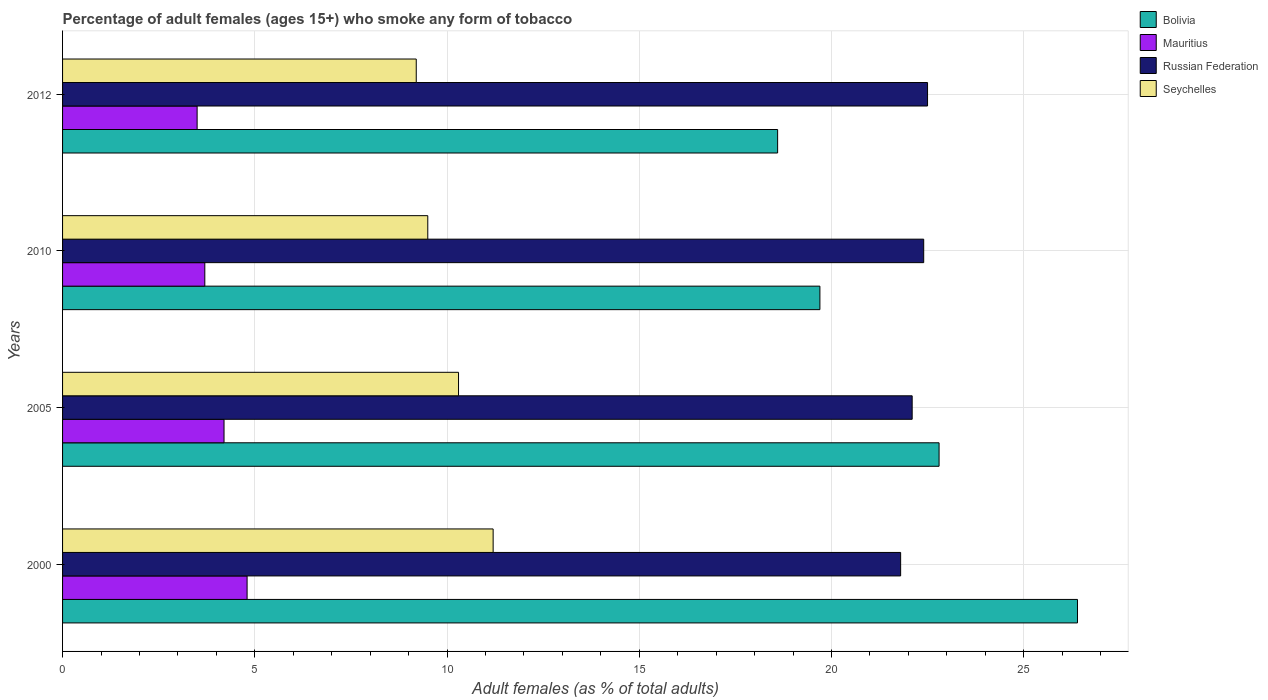How many bars are there on the 4th tick from the top?
Provide a short and direct response. 4. How many bars are there on the 3rd tick from the bottom?
Provide a succinct answer. 4. What is the label of the 2nd group of bars from the top?
Offer a terse response. 2010. In how many cases, is the number of bars for a given year not equal to the number of legend labels?
Provide a short and direct response. 0. Across all years, what is the maximum percentage of adult females who smoke in Mauritius?
Ensure brevity in your answer.  4.8. What is the total percentage of adult females who smoke in Mauritius in the graph?
Your response must be concise. 16.2. What is the difference between the percentage of adult females who smoke in Bolivia in 2000 and that in 2010?
Your answer should be compact. 6.7. What is the difference between the percentage of adult females who smoke in Bolivia in 2000 and the percentage of adult females who smoke in Seychelles in 2012?
Your answer should be compact. 17.2. What is the average percentage of adult females who smoke in Mauritius per year?
Your answer should be compact. 4.05. In the year 2010, what is the difference between the percentage of adult females who smoke in Mauritius and percentage of adult females who smoke in Bolivia?
Your answer should be very brief. -16. What is the ratio of the percentage of adult females who smoke in Russian Federation in 2000 to that in 2010?
Provide a succinct answer. 0.97. Is the percentage of adult females who smoke in Bolivia in 2000 less than that in 2012?
Ensure brevity in your answer.  No. Is the difference between the percentage of adult females who smoke in Mauritius in 2000 and 2012 greater than the difference between the percentage of adult females who smoke in Bolivia in 2000 and 2012?
Keep it short and to the point. No. What is the difference between the highest and the second highest percentage of adult females who smoke in Russian Federation?
Offer a very short reply. 0.1. What is the difference between the highest and the lowest percentage of adult females who smoke in Bolivia?
Offer a very short reply. 7.8. In how many years, is the percentage of adult females who smoke in Seychelles greater than the average percentage of adult females who smoke in Seychelles taken over all years?
Provide a succinct answer. 2. What does the 1st bar from the top in 2005 represents?
Your response must be concise. Seychelles. What does the 1st bar from the bottom in 2005 represents?
Your answer should be compact. Bolivia. Is it the case that in every year, the sum of the percentage of adult females who smoke in Bolivia and percentage of adult females who smoke in Russian Federation is greater than the percentage of adult females who smoke in Seychelles?
Offer a very short reply. Yes. How many bars are there?
Provide a short and direct response. 16. Are all the bars in the graph horizontal?
Provide a short and direct response. Yes. How many years are there in the graph?
Your response must be concise. 4. Are the values on the major ticks of X-axis written in scientific E-notation?
Offer a very short reply. No. Does the graph contain any zero values?
Ensure brevity in your answer.  No. What is the title of the graph?
Your answer should be compact. Percentage of adult females (ages 15+) who smoke any form of tobacco. Does "Morocco" appear as one of the legend labels in the graph?
Provide a short and direct response. No. What is the label or title of the X-axis?
Offer a terse response. Adult females (as % of total adults). What is the Adult females (as % of total adults) in Bolivia in 2000?
Your answer should be compact. 26.4. What is the Adult females (as % of total adults) in Russian Federation in 2000?
Offer a terse response. 21.8. What is the Adult females (as % of total adults) of Bolivia in 2005?
Make the answer very short. 22.8. What is the Adult females (as % of total adults) of Russian Federation in 2005?
Your answer should be very brief. 22.1. What is the Adult females (as % of total adults) in Seychelles in 2005?
Offer a very short reply. 10.3. What is the Adult females (as % of total adults) of Mauritius in 2010?
Your answer should be compact. 3.7. What is the Adult females (as % of total adults) of Russian Federation in 2010?
Offer a terse response. 22.4. What is the Adult females (as % of total adults) in Bolivia in 2012?
Your response must be concise. 18.6. What is the Adult females (as % of total adults) in Mauritius in 2012?
Offer a terse response. 3.5. What is the Adult females (as % of total adults) in Seychelles in 2012?
Ensure brevity in your answer.  9.2. Across all years, what is the maximum Adult females (as % of total adults) in Bolivia?
Keep it short and to the point. 26.4. Across all years, what is the maximum Adult females (as % of total adults) of Mauritius?
Provide a succinct answer. 4.8. Across all years, what is the maximum Adult females (as % of total adults) of Seychelles?
Provide a short and direct response. 11.2. Across all years, what is the minimum Adult females (as % of total adults) of Mauritius?
Ensure brevity in your answer.  3.5. Across all years, what is the minimum Adult females (as % of total adults) in Russian Federation?
Your answer should be very brief. 21.8. What is the total Adult females (as % of total adults) in Bolivia in the graph?
Your answer should be compact. 87.5. What is the total Adult females (as % of total adults) of Russian Federation in the graph?
Ensure brevity in your answer.  88.8. What is the total Adult females (as % of total adults) in Seychelles in the graph?
Your response must be concise. 40.2. What is the difference between the Adult females (as % of total adults) of Mauritius in 2000 and that in 2005?
Offer a terse response. 0.6. What is the difference between the Adult females (as % of total adults) of Russian Federation in 2000 and that in 2005?
Your response must be concise. -0.3. What is the difference between the Adult females (as % of total adults) in Bolivia in 2000 and that in 2010?
Your response must be concise. 6.7. What is the difference between the Adult females (as % of total adults) in Mauritius in 2000 and that in 2010?
Your response must be concise. 1.1. What is the difference between the Adult females (as % of total adults) of Russian Federation in 2000 and that in 2010?
Offer a very short reply. -0.6. What is the difference between the Adult females (as % of total adults) in Mauritius in 2000 and that in 2012?
Your answer should be very brief. 1.3. What is the difference between the Adult females (as % of total adults) in Russian Federation in 2000 and that in 2012?
Your answer should be compact. -0.7. What is the difference between the Adult females (as % of total adults) in Seychelles in 2000 and that in 2012?
Offer a terse response. 2. What is the difference between the Adult females (as % of total adults) in Mauritius in 2005 and that in 2010?
Give a very brief answer. 0.5. What is the difference between the Adult females (as % of total adults) of Russian Federation in 2005 and that in 2010?
Give a very brief answer. -0.3. What is the difference between the Adult females (as % of total adults) in Bolivia in 2005 and that in 2012?
Give a very brief answer. 4.2. What is the difference between the Adult females (as % of total adults) of Russian Federation in 2005 and that in 2012?
Give a very brief answer. -0.4. What is the difference between the Adult females (as % of total adults) in Seychelles in 2005 and that in 2012?
Your answer should be very brief. 1.1. What is the difference between the Adult females (as % of total adults) of Bolivia in 2010 and that in 2012?
Provide a short and direct response. 1.1. What is the difference between the Adult females (as % of total adults) in Mauritius in 2010 and that in 2012?
Offer a very short reply. 0.2. What is the difference between the Adult females (as % of total adults) in Russian Federation in 2010 and that in 2012?
Provide a succinct answer. -0.1. What is the difference between the Adult females (as % of total adults) in Seychelles in 2010 and that in 2012?
Offer a terse response. 0.3. What is the difference between the Adult females (as % of total adults) of Bolivia in 2000 and the Adult females (as % of total adults) of Seychelles in 2005?
Make the answer very short. 16.1. What is the difference between the Adult females (as % of total adults) of Mauritius in 2000 and the Adult females (as % of total adults) of Russian Federation in 2005?
Make the answer very short. -17.3. What is the difference between the Adult females (as % of total adults) in Bolivia in 2000 and the Adult females (as % of total adults) in Mauritius in 2010?
Make the answer very short. 22.7. What is the difference between the Adult females (as % of total adults) in Mauritius in 2000 and the Adult females (as % of total adults) in Russian Federation in 2010?
Keep it short and to the point. -17.6. What is the difference between the Adult females (as % of total adults) in Russian Federation in 2000 and the Adult females (as % of total adults) in Seychelles in 2010?
Your answer should be compact. 12.3. What is the difference between the Adult females (as % of total adults) in Bolivia in 2000 and the Adult females (as % of total adults) in Mauritius in 2012?
Make the answer very short. 22.9. What is the difference between the Adult females (as % of total adults) of Bolivia in 2000 and the Adult females (as % of total adults) of Russian Federation in 2012?
Your answer should be very brief. 3.9. What is the difference between the Adult females (as % of total adults) of Bolivia in 2000 and the Adult females (as % of total adults) of Seychelles in 2012?
Your answer should be very brief. 17.2. What is the difference between the Adult females (as % of total adults) of Mauritius in 2000 and the Adult females (as % of total adults) of Russian Federation in 2012?
Provide a short and direct response. -17.7. What is the difference between the Adult females (as % of total adults) of Mauritius in 2000 and the Adult females (as % of total adults) of Seychelles in 2012?
Keep it short and to the point. -4.4. What is the difference between the Adult females (as % of total adults) in Bolivia in 2005 and the Adult females (as % of total adults) in Russian Federation in 2010?
Keep it short and to the point. 0.4. What is the difference between the Adult females (as % of total adults) in Bolivia in 2005 and the Adult females (as % of total adults) in Seychelles in 2010?
Your answer should be compact. 13.3. What is the difference between the Adult females (as % of total adults) of Mauritius in 2005 and the Adult females (as % of total adults) of Russian Federation in 2010?
Make the answer very short. -18.2. What is the difference between the Adult females (as % of total adults) in Russian Federation in 2005 and the Adult females (as % of total adults) in Seychelles in 2010?
Your answer should be compact. 12.6. What is the difference between the Adult females (as % of total adults) in Bolivia in 2005 and the Adult females (as % of total adults) in Mauritius in 2012?
Keep it short and to the point. 19.3. What is the difference between the Adult females (as % of total adults) of Bolivia in 2005 and the Adult females (as % of total adults) of Seychelles in 2012?
Provide a succinct answer. 13.6. What is the difference between the Adult females (as % of total adults) in Mauritius in 2005 and the Adult females (as % of total adults) in Russian Federation in 2012?
Provide a short and direct response. -18.3. What is the difference between the Adult females (as % of total adults) of Russian Federation in 2005 and the Adult females (as % of total adults) of Seychelles in 2012?
Ensure brevity in your answer.  12.9. What is the difference between the Adult females (as % of total adults) of Bolivia in 2010 and the Adult females (as % of total adults) of Mauritius in 2012?
Offer a terse response. 16.2. What is the difference between the Adult females (as % of total adults) in Bolivia in 2010 and the Adult females (as % of total adults) in Seychelles in 2012?
Provide a short and direct response. 10.5. What is the difference between the Adult females (as % of total adults) in Mauritius in 2010 and the Adult females (as % of total adults) in Russian Federation in 2012?
Keep it short and to the point. -18.8. What is the difference between the Adult females (as % of total adults) in Mauritius in 2010 and the Adult females (as % of total adults) in Seychelles in 2012?
Provide a short and direct response. -5.5. What is the difference between the Adult females (as % of total adults) in Russian Federation in 2010 and the Adult females (as % of total adults) in Seychelles in 2012?
Provide a succinct answer. 13.2. What is the average Adult females (as % of total adults) in Bolivia per year?
Keep it short and to the point. 21.88. What is the average Adult females (as % of total adults) of Mauritius per year?
Your answer should be very brief. 4.05. What is the average Adult females (as % of total adults) of Russian Federation per year?
Offer a terse response. 22.2. What is the average Adult females (as % of total adults) in Seychelles per year?
Ensure brevity in your answer.  10.05. In the year 2000, what is the difference between the Adult females (as % of total adults) of Bolivia and Adult females (as % of total adults) of Mauritius?
Ensure brevity in your answer.  21.6. In the year 2000, what is the difference between the Adult females (as % of total adults) of Bolivia and Adult females (as % of total adults) of Russian Federation?
Your response must be concise. 4.6. In the year 2000, what is the difference between the Adult females (as % of total adults) in Mauritius and Adult females (as % of total adults) in Seychelles?
Offer a terse response. -6.4. In the year 2000, what is the difference between the Adult females (as % of total adults) of Russian Federation and Adult females (as % of total adults) of Seychelles?
Your answer should be compact. 10.6. In the year 2005, what is the difference between the Adult females (as % of total adults) in Bolivia and Adult females (as % of total adults) in Seychelles?
Provide a succinct answer. 12.5. In the year 2005, what is the difference between the Adult females (as % of total adults) in Mauritius and Adult females (as % of total adults) in Russian Federation?
Provide a succinct answer. -17.9. In the year 2005, what is the difference between the Adult females (as % of total adults) in Russian Federation and Adult females (as % of total adults) in Seychelles?
Keep it short and to the point. 11.8. In the year 2010, what is the difference between the Adult females (as % of total adults) in Bolivia and Adult females (as % of total adults) in Russian Federation?
Give a very brief answer. -2.7. In the year 2010, what is the difference between the Adult females (as % of total adults) of Bolivia and Adult females (as % of total adults) of Seychelles?
Make the answer very short. 10.2. In the year 2010, what is the difference between the Adult females (as % of total adults) of Mauritius and Adult females (as % of total adults) of Russian Federation?
Your response must be concise. -18.7. In the year 2010, what is the difference between the Adult females (as % of total adults) in Mauritius and Adult females (as % of total adults) in Seychelles?
Your answer should be very brief. -5.8. In the year 2010, what is the difference between the Adult females (as % of total adults) in Russian Federation and Adult females (as % of total adults) in Seychelles?
Offer a terse response. 12.9. In the year 2012, what is the difference between the Adult females (as % of total adults) in Bolivia and Adult females (as % of total adults) in Mauritius?
Your answer should be compact. 15.1. In the year 2012, what is the difference between the Adult females (as % of total adults) of Bolivia and Adult females (as % of total adults) of Russian Federation?
Give a very brief answer. -3.9. In the year 2012, what is the difference between the Adult females (as % of total adults) in Bolivia and Adult females (as % of total adults) in Seychelles?
Provide a succinct answer. 9.4. In the year 2012, what is the difference between the Adult females (as % of total adults) in Mauritius and Adult females (as % of total adults) in Seychelles?
Provide a succinct answer. -5.7. In the year 2012, what is the difference between the Adult females (as % of total adults) in Russian Federation and Adult females (as % of total adults) in Seychelles?
Ensure brevity in your answer.  13.3. What is the ratio of the Adult females (as % of total adults) in Bolivia in 2000 to that in 2005?
Make the answer very short. 1.16. What is the ratio of the Adult females (as % of total adults) of Russian Federation in 2000 to that in 2005?
Keep it short and to the point. 0.99. What is the ratio of the Adult females (as % of total adults) of Seychelles in 2000 to that in 2005?
Offer a terse response. 1.09. What is the ratio of the Adult females (as % of total adults) of Bolivia in 2000 to that in 2010?
Make the answer very short. 1.34. What is the ratio of the Adult females (as % of total adults) of Mauritius in 2000 to that in 2010?
Offer a very short reply. 1.3. What is the ratio of the Adult females (as % of total adults) in Russian Federation in 2000 to that in 2010?
Make the answer very short. 0.97. What is the ratio of the Adult females (as % of total adults) in Seychelles in 2000 to that in 2010?
Provide a short and direct response. 1.18. What is the ratio of the Adult females (as % of total adults) of Bolivia in 2000 to that in 2012?
Your response must be concise. 1.42. What is the ratio of the Adult females (as % of total adults) in Mauritius in 2000 to that in 2012?
Your response must be concise. 1.37. What is the ratio of the Adult females (as % of total adults) of Russian Federation in 2000 to that in 2012?
Provide a succinct answer. 0.97. What is the ratio of the Adult females (as % of total adults) of Seychelles in 2000 to that in 2012?
Give a very brief answer. 1.22. What is the ratio of the Adult females (as % of total adults) in Bolivia in 2005 to that in 2010?
Make the answer very short. 1.16. What is the ratio of the Adult females (as % of total adults) in Mauritius in 2005 to that in 2010?
Your answer should be very brief. 1.14. What is the ratio of the Adult females (as % of total adults) in Russian Federation in 2005 to that in 2010?
Make the answer very short. 0.99. What is the ratio of the Adult females (as % of total adults) in Seychelles in 2005 to that in 2010?
Ensure brevity in your answer.  1.08. What is the ratio of the Adult females (as % of total adults) of Bolivia in 2005 to that in 2012?
Make the answer very short. 1.23. What is the ratio of the Adult females (as % of total adults) of Russian Federation in 2005 to that in 2012?
Your answer should be compact. 0.98. What is the ratio of the Adult females (as % of total adults) in Seychelles in 2005 to that in 2012?
Ensure brevity in your answer.  1.12. What is the ratio of the Adult females (as % of total adults) in Bolivia in 2010 to that in 2012?
Keep it short and to the point. 1.06. What is the ratio of the Adult females (as % of total adults) of Mauritius in 2010 to that in 2012?
Offer a very short reply. 1.06. What is the ratio of the Adult females (as % of total adults) of Russian Federation in 2010 to that in 2012?
Ensure brevity in your answer.  1. What is the ratio of the Adult females (as % of total adults) of Seychelles in 2010 to that in 2012?
Ensure brevity in your answer.  1.03. What is the difference between the highest and the second highest Adult females (as % of total adults) in Seychelles?
Provide a short and direct response. 0.9. What is the difference between the highest and the lowest Adult females (as % of total adults) of Russian Federation?
Provide a succinct answer. 0.7. What is the difference between the highest and the lowest Adult females (as % of total adults) in Seychelles?
Your answer should be very brief. 2. 